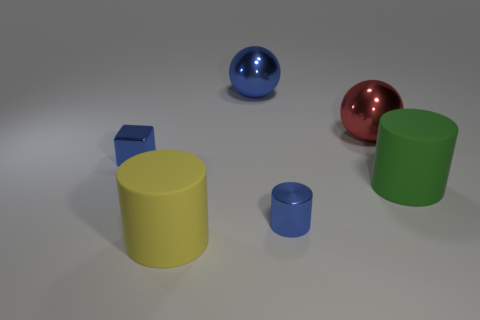Do the yellow object in front of the red metallic ball and the blue cylinder have the same material?
Your response must be concise. No. Is the shape of the yellow rubber object the same as the green matte object?
Offer a very short reply. Yes. There is a blue metallic thing on the left side of the blue shiny object behind the tiny shiny thing to the left of the big blue object; what shape is it?
Your answer should be compact. Cube. There is a small blue metal object that is in front of the large green cylinder; is it the same shape as the big thing on the right side of the large red metal thing?
Your answer should be very brief. Yes. Are there any red spheres made of the same material as the small block?
Ensure brevity in your answer.  Yes. There is a small shiny thing that is on the right side of the big matte thing that is in front of the small blue shiny object in front of the green object; what is its color?
Give a very brief answer. Blue. Is the material of the cylinder that is behind the metallic cylinder the same as the large cylinder to the left of the green cylinder?
Your response must be concise. Yes. There is a tiny thing on the left side of the big blue metallic sphere; what shape is it?
Provide a short and direct response. Cube. How many objects are large matte cylinders or big rubber cylinders on the right side of the blue cylinder?
Keep it short and to the point. 2. Do the red ball and the big green object have the same material?
Keep it short and to the point. No. 